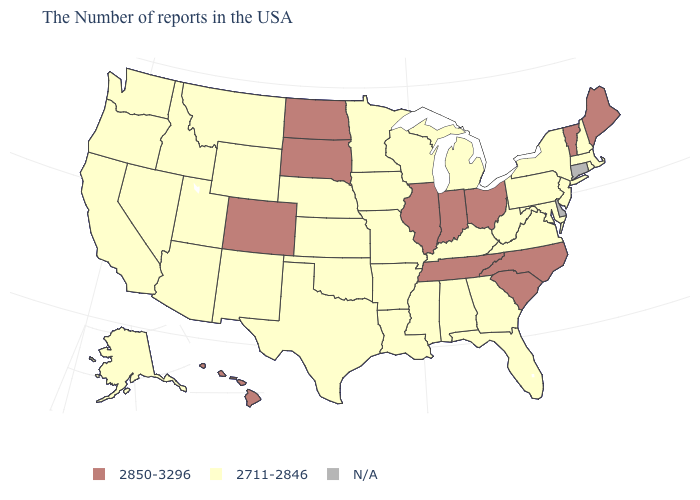What is the value of New Hampshire?
Quick response, please. 2711-2846. What is the value of Florida?
Write a very short answer. 2711-2846. How many symbols are there in the legend?
Short answer required. 3. Name the states that have a value in the range N/A?
Keep it brief. Connecticut, Delaware. Name the states that have a value in the range 2711-2846?
Write a very short answer. Massachusetts, Rhode Island, New Hampshire, New York, New Jersey, Maryland, Pennsylvania, Virginia, West Virginia, Florida, Georgia, Michigan, Kentucky, Alabama, Wisconsin, Mississippi, Louisiana, Missouri, Arkansas, Minnesota, Iowa, Kansas, Nebraska, Oklahoma, Texas, Wyoming, New Mexico, Utah, Montana, Arizona, Idaho, Nevada, California, Washington, Oregon, Alaska. How many symbols are there in the legend?
Quick response, please. 3. What is the highest value in the USA?
Keep it brief. 2850-3296. Name the states that have a value in the range N/A?
Keep it brief. Connecticut, Delaware. Does the first symbol in the legend represent the smallest category?
Keep it brief. No. Which states hav the highest value in the South?
Write a very short answer. North Carolina, South Carolina, Tennessee. Does the first symbol in the legend represent the smallest category?
Write a very short answer. No. What is the highest value in the USA?
Be succinct. 2850-3296. Name the states that have a value in the range 2711-2846?
Short answer required. Massachusetts, Rhode Island, New Hampshire, New York, New Jersey, Maryland, Pennsylvania, Virginia, West Virginia, Florida, Georgia, Michigan, Kentucky, Alabama, Wisconsin, Mississippi, Louisiana, Missouri, Arkansas, Minnesota, Iowa, Kansas, Nebraska, Oklahoma, Texas, Wyoming, New Mexico, Utah, Montana, Arizona, Idaho, Nevada, California, Washington, Oregon, Alaska. 